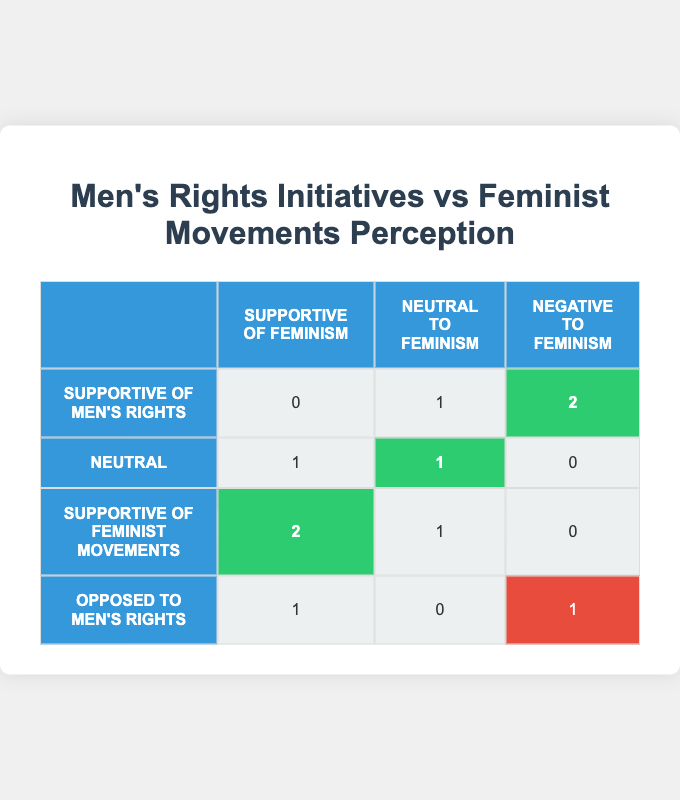What is the number of respondents who are supportive of men's rights initiatives and have a negative perception of feminism? From the table, we look at the row for "Supportive of Men's Rights" and the column for "Negative to Feminism." The value is 2.
Answer: 2 How many respondents are neutral about feminism and neutral about men's rights initiatives? In the table, we find the row for "Neutral" and the column for "Neutral to Feminism." The value is 1.
Answer: 1 What is the total number of respondents who are opposed to men's rights initiatives? We sum the values in the "Opposed to Men's Rights" row across all columns: 1 (Supportive of Feminism) + 0 (Neutral to Feminism) + 1 (Negative to Feminism) = 2.
Answer: 2 Is there any respondent who is supportive of both men's rights initiatives and feminist movements? Looking at the table, we check the "Supportive of Men's Rights" row against the "Supportive of Feminism" column. The value is 0, indicating no respondents fit both criteria.
Answer: No What percent of respondents who are supportive of feminist movements have a neutral perception of feminism? The number is taken from the "Supportive of Feminist Movements" row, specifically for "Neutral to Feminism," which is 1 out of the total 3 supportive respondents (1 + 2 + 0 = 3). The calculation 1/3 = 0.33 or 33.33%.
Answer: 33.33% What is the ratio of respondents who are supportive of feminist movements to those who are opposed to men's rights initiatives? The number of supporters of feminist movements is 3, while the number of those opposed to men's rights is 2. Therefore, the ratio is 3:2.
Answer: 3:2 